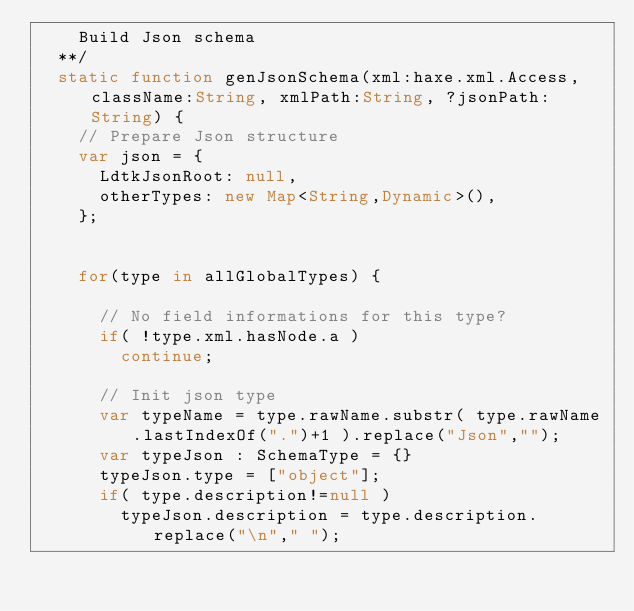<code> <loc_0><loc_0><loc_500><loc_500><_Haxe_>		Build Json schema
	**/
	static function genJsonSchema(xml:haxe.xml.Access, className:String, xmlPath:String, ?jsonPath:String) {
		// Prepare Json structure
		var json = {
			LdtkJsonRoot: null,
			otherTypes: new Map<String,Dynamic>(),
		};


		for(type in allGlobalTypes) {

			// No field informations for this type?
			if( !type.xml.hasNode.a )
				continue;

			// Init json type
			var typeName = type.rawName.substr( type.rawName.lastIndexOf(".")+1 ).replace("Json","");
			var typeJson : SchemaType = {}
			typeJson.type = ["object"];
			if( type.description!=null )
				typeJson.description = type.description.replace("\n"," ");</code> 